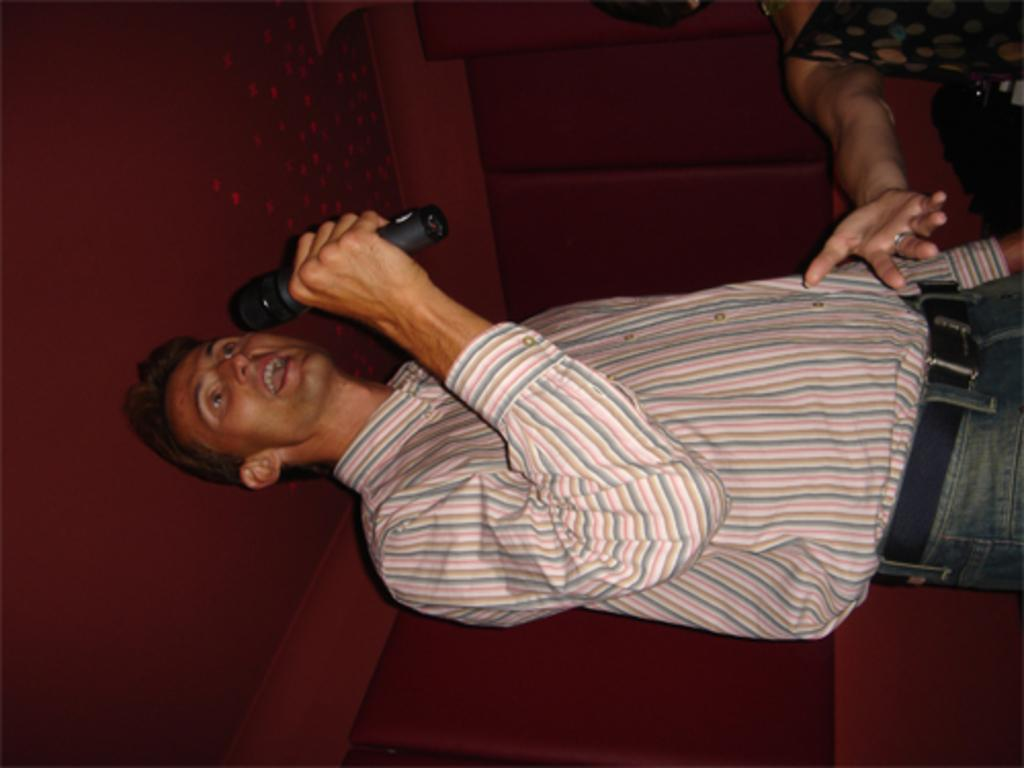Who is the main subject in the image? There is a man in the image. What is the man holding in his hand? The man is holding a mic in his hand. What is the man doing with the mic? The man is speaking. What can be seen in the background of the image? There is a wall in the background of the image. How many dimes can be seen falling through the hole in the image? There are no dimes or holes present in the image. What type of shake is the man making in the image? The man is not making any shake in the image; he is holding a mic and speaking. 